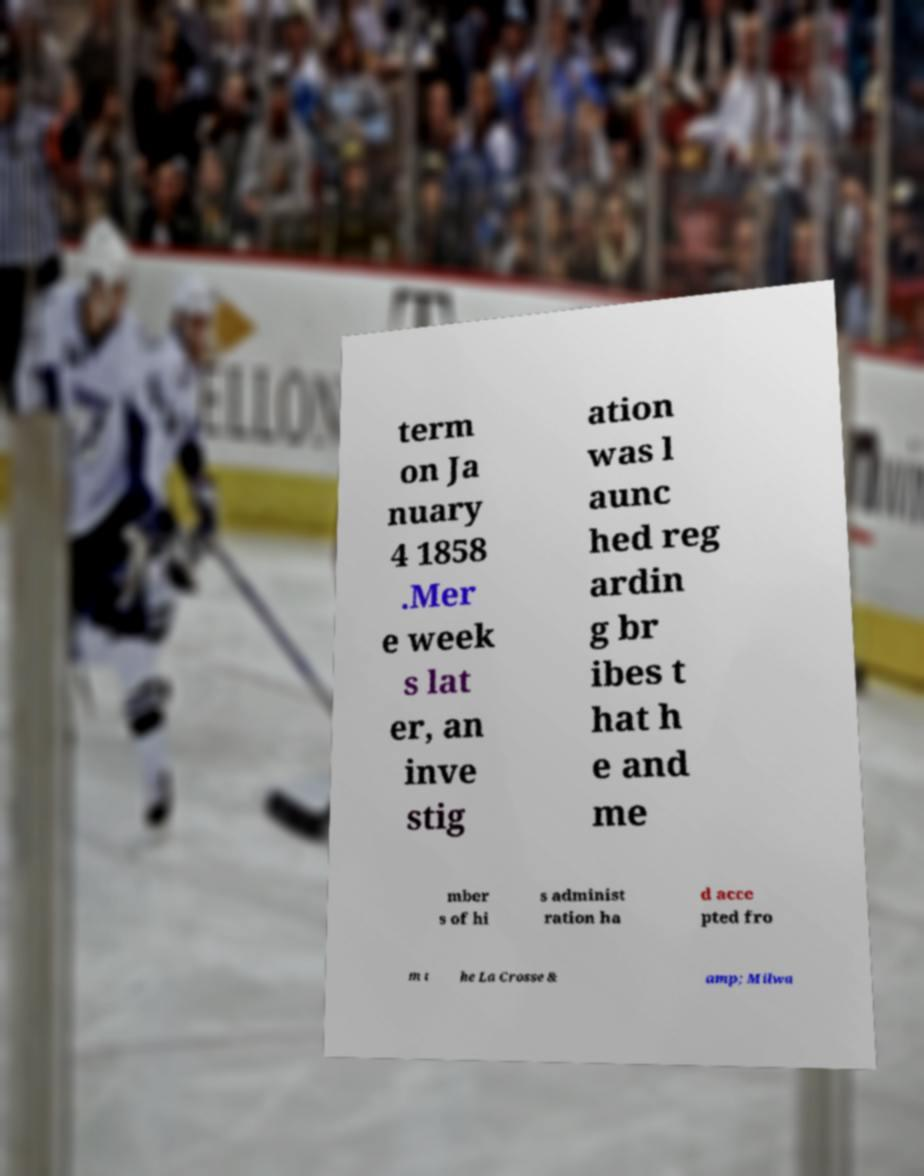What messages or text are displayed in this image? I need them in a readable, typed format. term on Ja nuary 4 1858 .Mer e week s lat er, an inve stig ation was l aunc hed reg ardin g br ibes t hat h e and me mber s of hi s administ ration ha d acce pted fro m t he La Crosse & amp; Milwa 